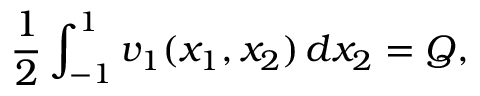Convert formula to latex. <formula><loc_0><loc_0><loc_500><loc_500>\frac { 1 } { 2 } \int _ { - 1 } ^ { 1 } v _ { 1 } ( x _ { 1 } , x _ { 2 } ) \, d x _ { 2 } = Q ,</formula> 